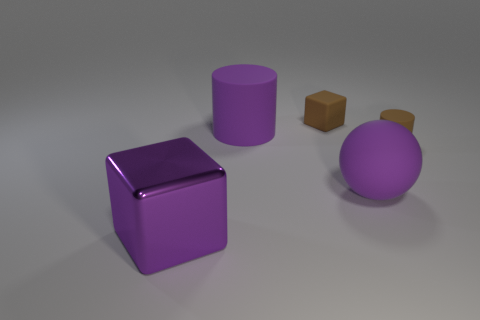What size is the brown cylinder?
Ensure brevity in your answer.  Small. How many big things have the same color as the large cylinder?
Offer a very short reply. 2. There is a purple thing on the right side of the cube that is behind the large shiny thing; are there any rubber cubes to the left of it?
Offer a terse response. Yes. The matte object that is the same size as the purple rubber sphere is what shape?
Provide a short and direct response. Cylinder. How many large objects are purple cylinders or cyan metal blocks?
Give a very brief answer. 1. The large cylinder that is the same material as the sphere is what color?
Ensure brevity in your answer.  Purple. Do the tiny thing to the left of the tiny cylinder and the brown object that is right of the brown matte cube have the same shape?
Give a very brief answer. No. What number of shiny things are either tiny brown cylinders or cubes?
Your response must be concise. 1. There is a cylinder that is the same color as the shiny cube; what is it made of?
Ensure brevity in your answer.  Rubber. Are there any other things that have the same shape as the big purple metallic thing?
Provide a succinct answer. Yes. 